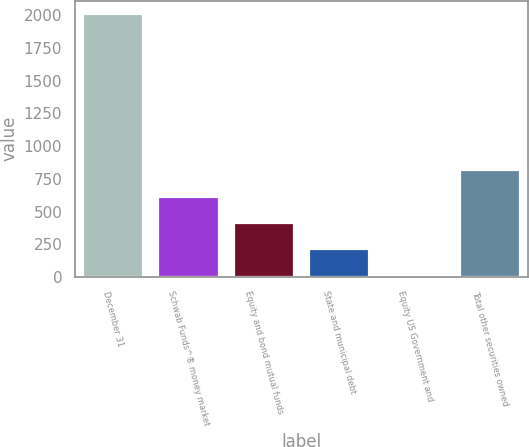Convert chart to OTSL. <chart><loc_0><loc_0><loc_500><loc_500><bar_chart><fcel>December 31<fcel>Schwab Funds^® money market<fcel>Equity and bond mutual funds<fcel>State and municipal debt<fcel>Equity US Government and<fcel>Total other securities owned<nl><fcel>2013<fcel>615.1<fcel>415.4<fcel>215.7<fcel>16<fcel>814.8<nl></chart> 